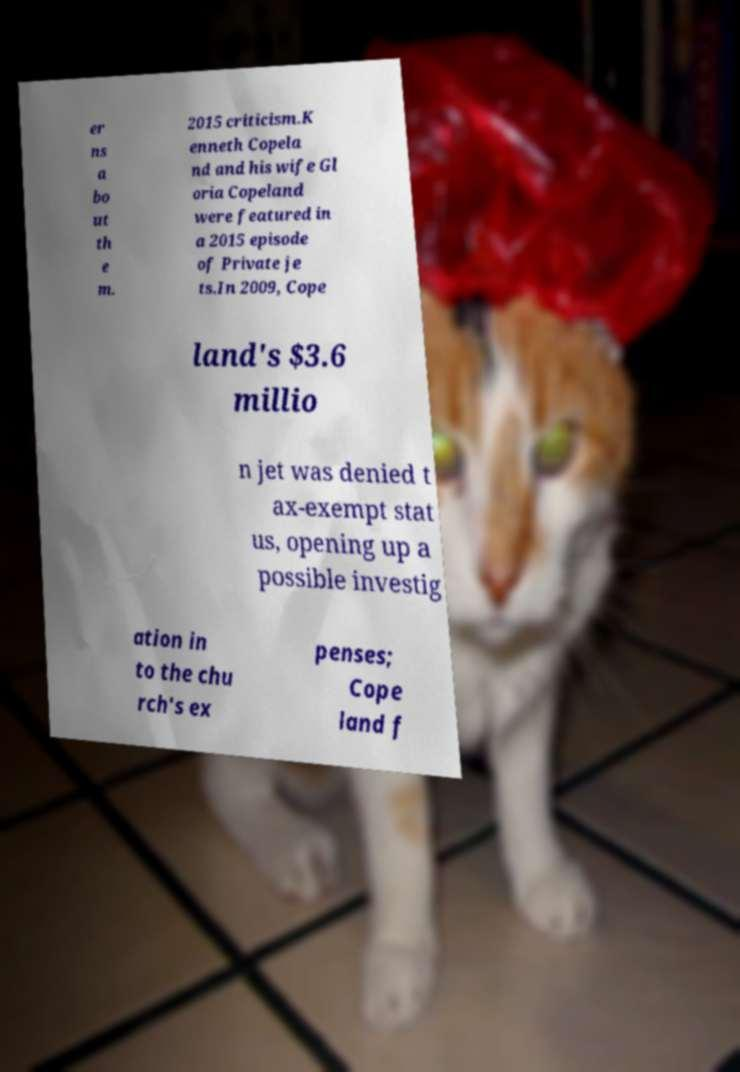There's text embedded in this image that I need extracted. Can you transcribe it verbatim? er ns a bo ut th e m. 2015 criticism.K enneth Copela nd and his wife Gl oria Copeland were featured in a 2015 episode of Private je ts.In 2009, Cope land's $3.6 millio n jet was denied t ax-exempt stat us, opening up a possible investig ation in to the chu rch's ex penses; Cope land f 